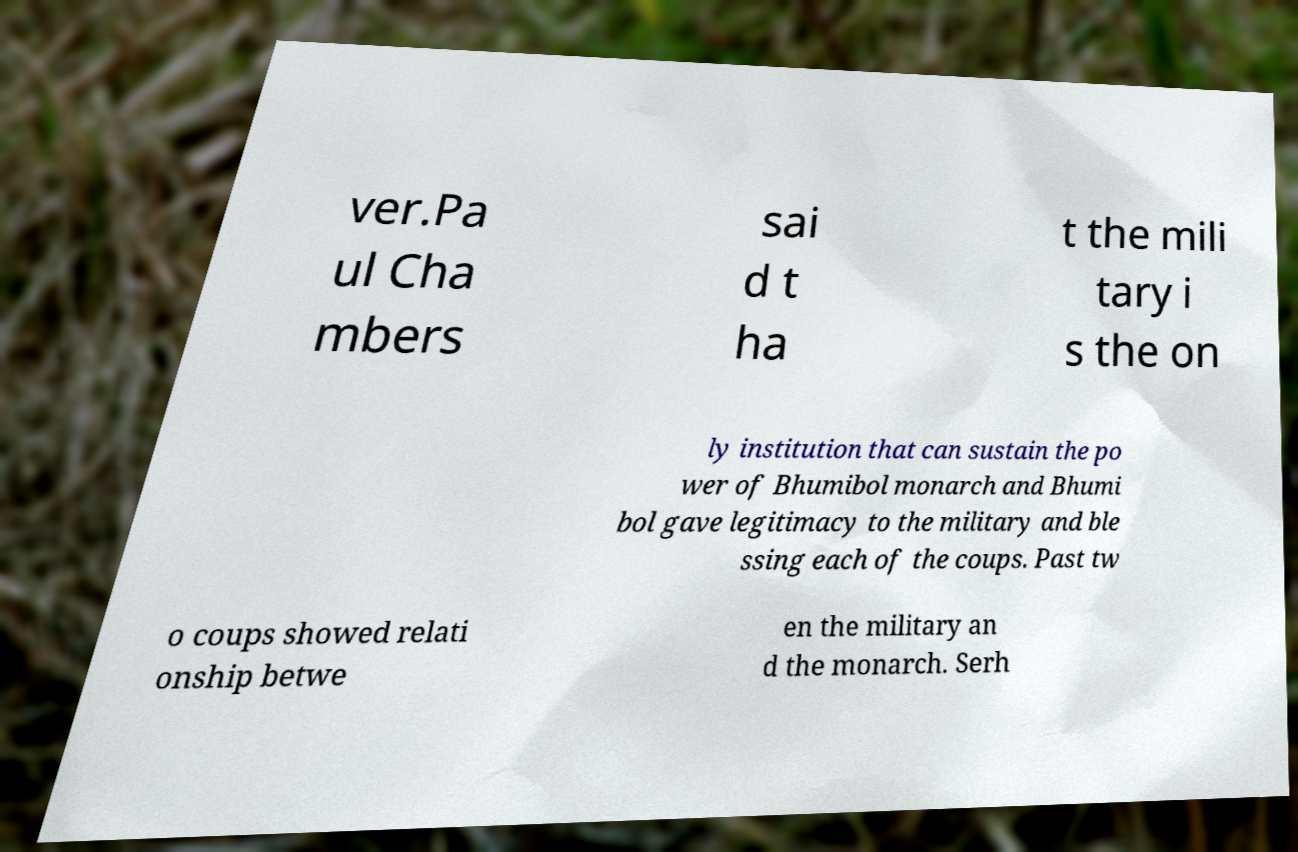Can you read and provide the text displayed in the image?This photo seems to have some interesting text. Can you extract and type it out for me? ver.Pa ul Cha mbers sai d t ha t the mili tary i s the on ly institution that can sustain the po wer of Bhumibol monarch and Bhumi bol gave legitimacy to the military and ble ssing each of the coups. Past tw o coups showed relati onship betwe en the military an d the monarch. Serh 